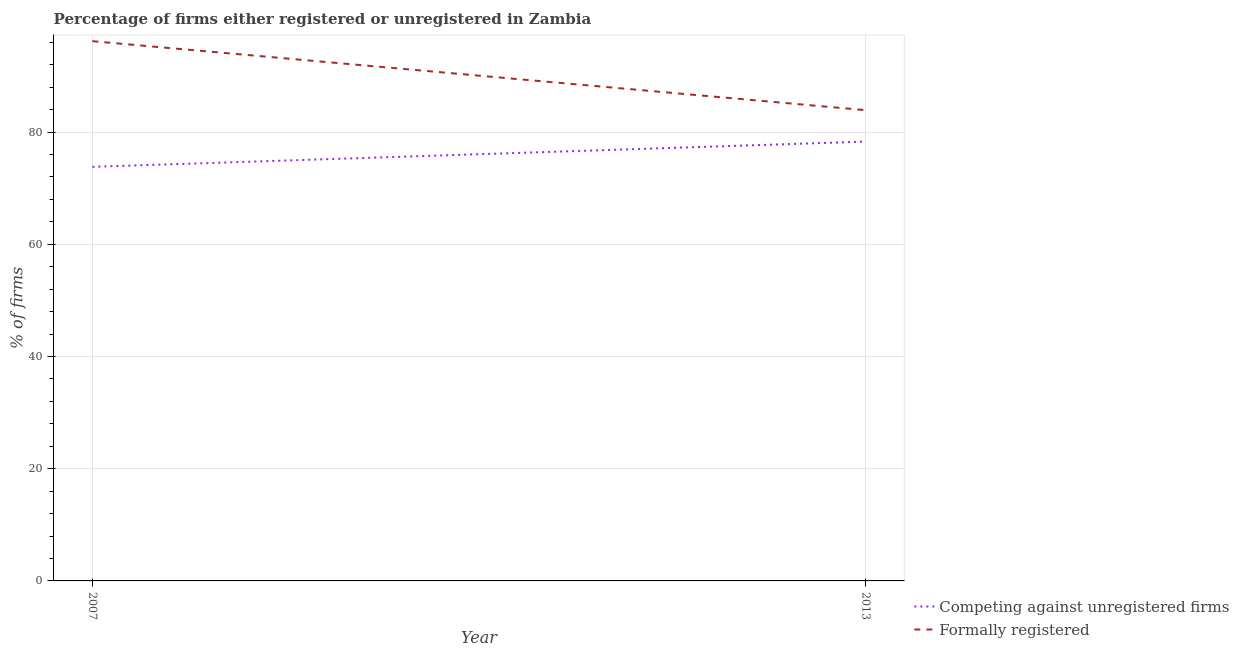Is the number of lines equal to the number of legend labels?
Provide a short and direct response. Yes. What is the percentage of formally registered firms in 2013?
Make the answer very short. 83.9. Across all years, what is the maximum percentage of formally registered firms?
Make the answer very short. 96.2. Across all years, what is the minimum percentage of registered firms?
Your response must be concise. 73.8. In which year was the percentage of registered firms minimum?
Ensure brevity in your answer.  2007. What is the total percentage of formally registered firms in the graph?
Your answer should be compact. 180.1. What is the difference between the percentage of registered firms in 2007 and that in 2013?
Offer a terse response. -4.5. What is the difference between the percentage of formally registered firms in 2013 and the percentage of registered firms in 2007?
Make the answer very short. 10.1. What is the average percentage of registered firms per year?
Give a very brief answer. 76.05. In the year 2013, what is the difference between the percentage of registered firms and percentage of formally registered firms?
Your response must be concise. -5.6. In how many years, is the percentage of formally registered firms greater than 28 %?
Your response must be concise. 2. What is the ratio of the percentage of registered firms in 2007 to that in 2013?
Provide a succinct answer. 0.94. Is the percentage of formally registered firms in 2007 less than that in 2013?
Make the answer very short. No. In how many years, is the percentage of formally registered firms greater than the average percentage of formally registered firms taken over all years?
Provide a succinct answer. 1. Are the values on the major ticks of Y-axis written in scientific E-notation?
Your answer should be compact. No. Does the graph contain grids?
Offer a very short reply. Yes. Where does the legend appear in the graph?
Offer a terse response. Bottom right. How are the legend labels stacked?
Provide a succinct answer. Vertical. What is the title of the graph?
Your answer should be compact. Percentage of firms either registered or unregistered in Zambia. What is the label or title of the X-axis?
Provide a succinct answer. Year. What is the label or title of the Y-axis?
Ensure brevity in your answer.  % of firms. What is the % of firms in Competing against unregistered firms in 2007?
Offer a very short reply. 73.8. What is the % of firms in Formally registered in 2007?
Your answer should be compact. 96.2. What is the % of firms of Competing against unregistered firms in 2013?
Your answer should be very brief. 78.3. What is the % of firms in Formally registered in 2013?
Provide a short and direct response. 83.9. Across all years, what is the maximum % of firms in Competing against unregistered firms?
Ensure brevity in your answer.  78.3. Across all years, what is the maximum % of firms in Formally registered?
Provide a short and direct response. 96.2. Across all years, what is the minimum % of firms in Competing against unregistered firms?
Your answer should be very brief. 73.8. Across all years, what is the minimum % of firms in Formally registered?
Offer a terse response. 83.9. What is the total % of firms of Competing against unregistered firms in the graph?
Your answer should be compact. 152.1. What is the total % of firms in Formally registered in the graph?
Provide a short and direct response. 180.1. What is the difference between the % of firms in Competing against unregistered firms in 2007 and that in 2013?
Your answer should be very brief. -4.5. What is the average % of firms in Competing against unregistered firms per year?
Offer a very short reply. 76.05. What is the average % of firms of Formally registered per year?
Ensure brevity in your answer.  90.05. In the year 2007, what is the difference between the % of firms of Competing against unregistered firms and % of firms of Formally registered?
Provide a short and direct response. -22.4. In the year 2013, what is the difference between the % of firms in Competing against unregistered firms and % of firms in Formally registered?
Keep it short and to the point. -5.6. What is the ratio of the % of firms in Competing against unregistered firms in 2007 to that in 2013?
Give a very brief answer. 0.94. What is the ratio of the % of firms in Formally registered in 2007 to that in 2013?
Your response must be concise. 1.15. What is the difference between the highest and the second highest % of firms of Competing against unregistered firms?
Ensure brevity in your answer.  4.5. What is the difference between the highest and the lowest % of firms in Formally registered?
Provide a short and direct response. 12.3. 